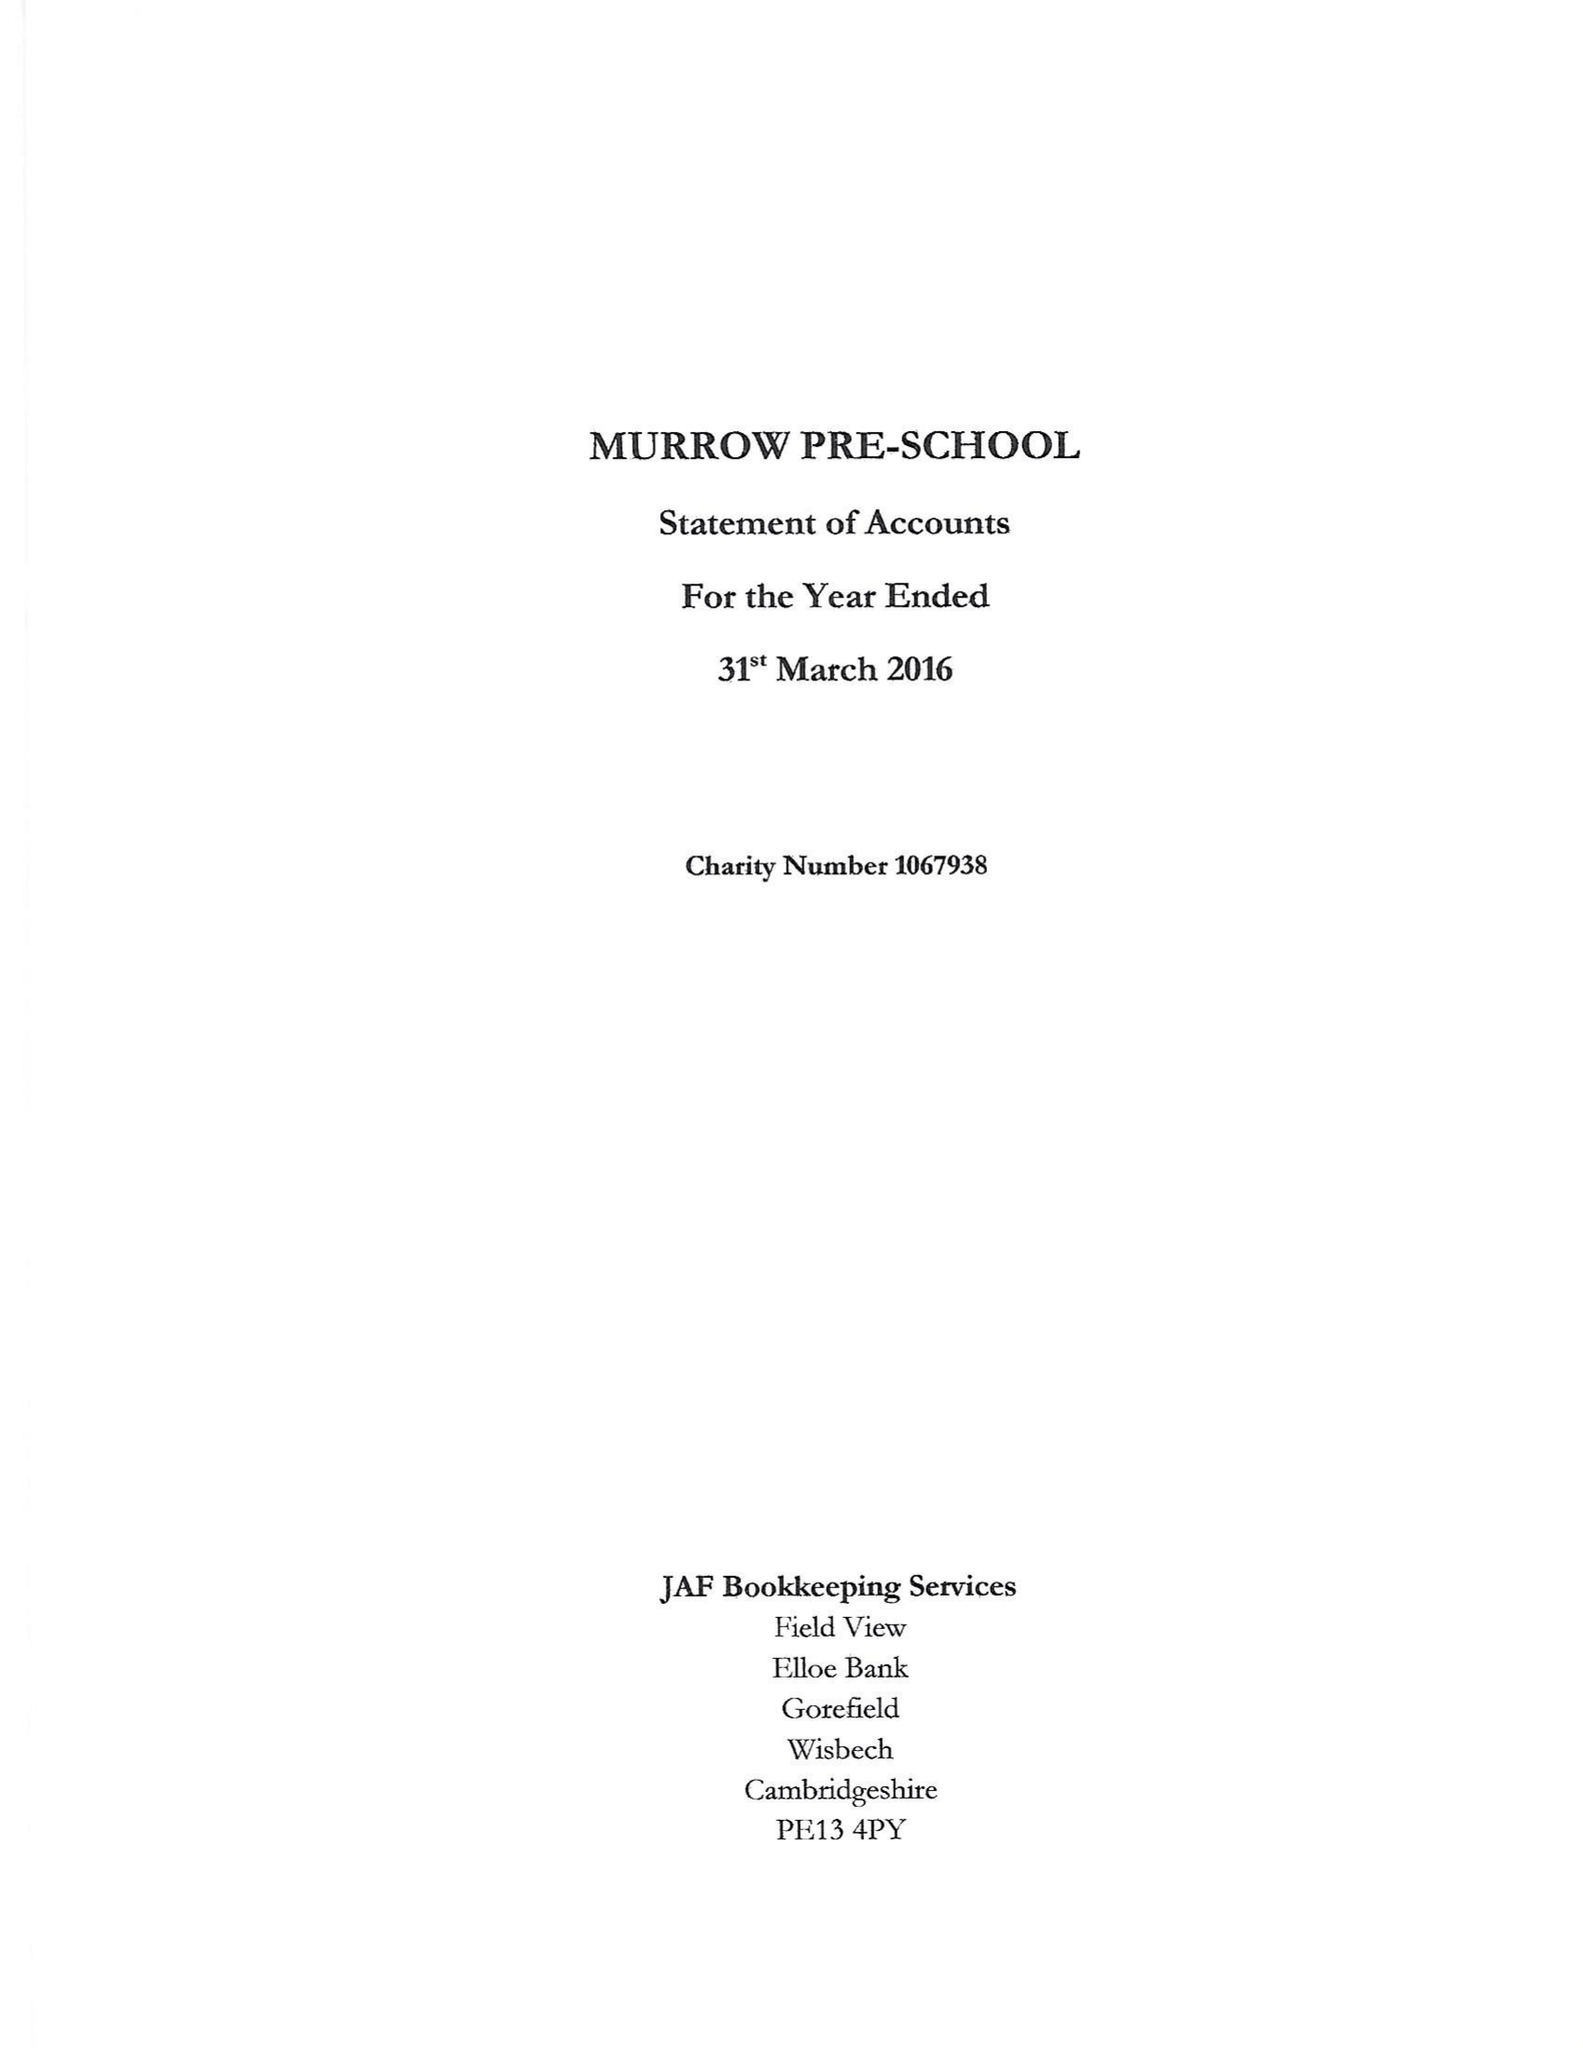What is the value for the address__street_line?
Answer the question using a single word or phrase. 73 MURROW BANK 